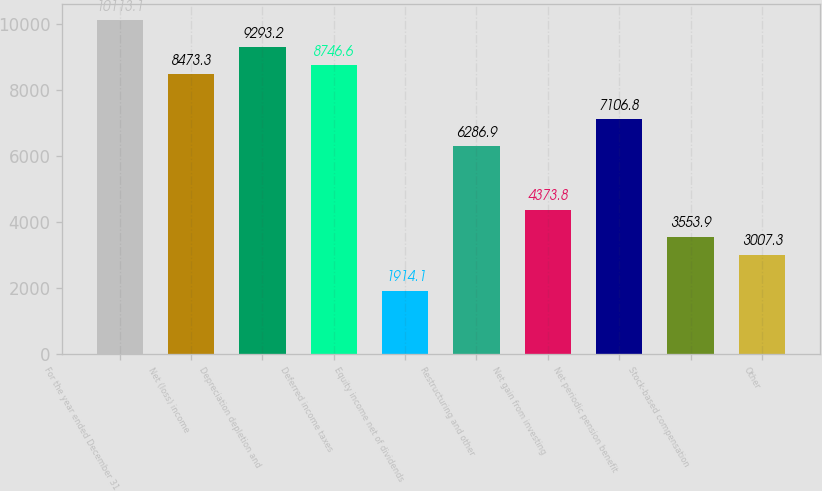Convert chart. <chart><loc_0><loc_0><loc_500><loc_500><bar_chart><fcel>For the year ended December 31<fcel>Net (loss) income<fcel>Depreciation depletion and<fcel>Deferred income taxes<fcel>Equity income net of dividends<fcel>Restructuring and other<fcel>Net gain from investing<fcel>Net periodic pension benefit<fcel>Stock-based compensation<fcel>Other<nl><fcel>10113.1<fcel>8473.3<fcel>9293.2<fcel>8746.6<fcel>1914.1<fcel>6286.9<fcel>4373.8<fcel>7106.8<fcel>3553.9<fcel>3007.3<nl></chart> 